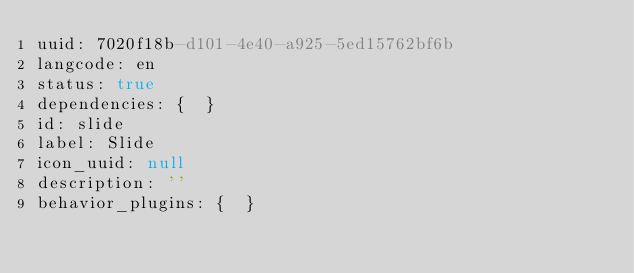Convert code to text. <code><loc_0><loc_0><loc_500><loc_500><_YAML_>uuid: 7020f18b-d101-4e40-a925-5ed15762bf6b
langcode: en
status: true
dependencies: {  }
id: slide
label: Slide
icon_uuid: null
description: ''
behavior_plugins: {  }
</code> 